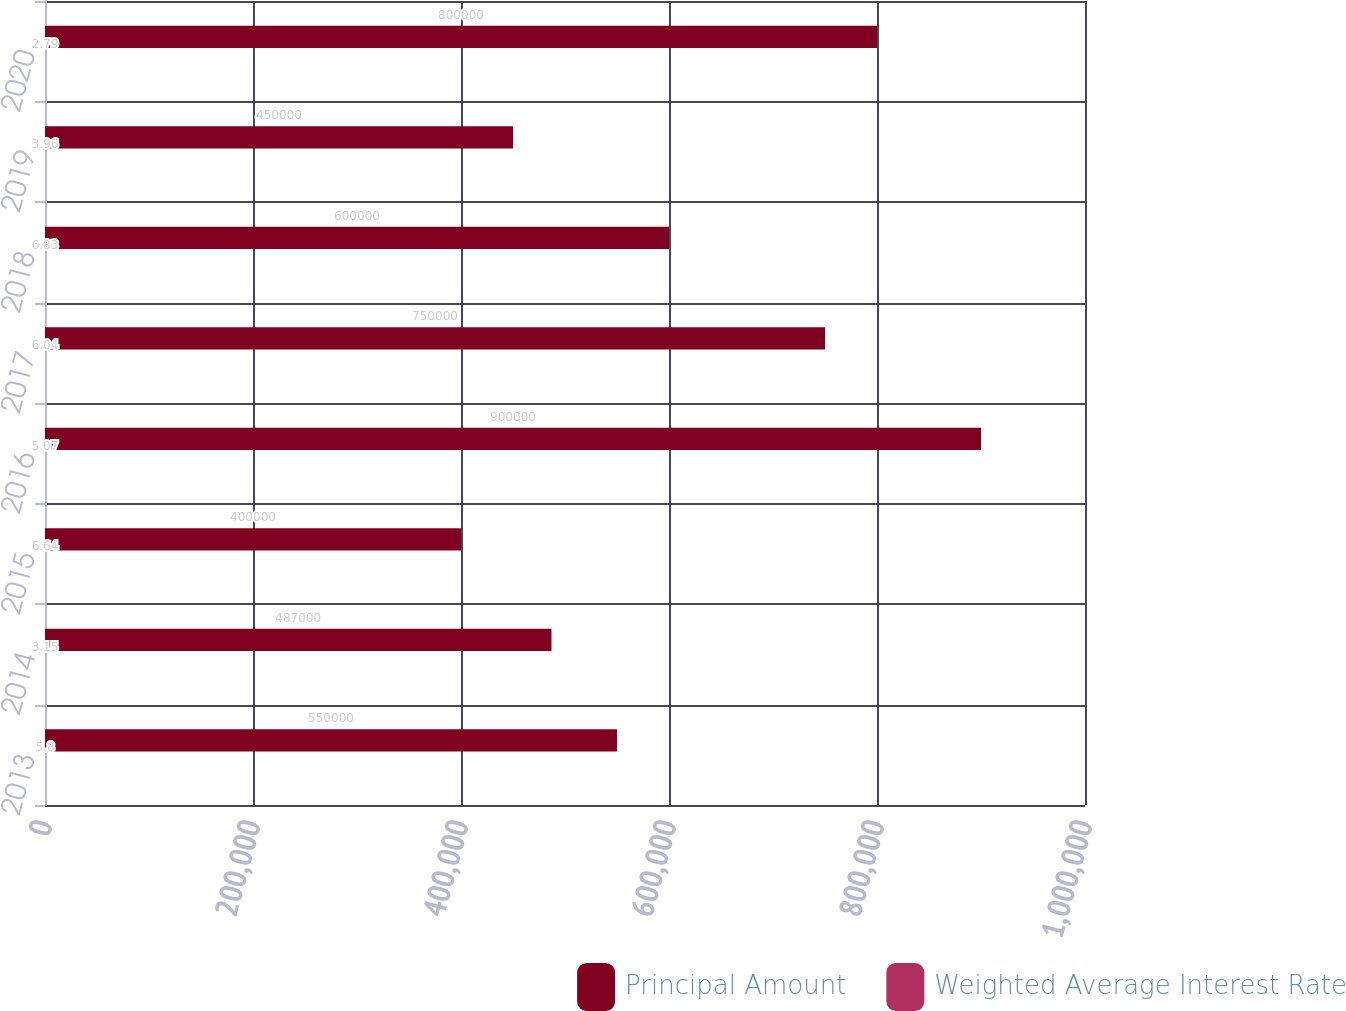Convert chart. <chart><loc_0><loc_0><loc_500><loc_500><stacked_bar_chart><ecel><fcel>2013<fcel>2014<fcel>2015<fcel>2016<fcel>2017<fcel>2018<fcel>2019<fcel>2020<nl><fcel>Principal Amount<fcel>550000<fcel>487000<fcel>400000<fcel>900000<fcel>750000<fcel>600000<fcel>450000<fcel>800000<nl><fcel>Weighted Average Interest Rate<fcel>5.8<fcel>3.15<fcel>6.64<fcel>5.07<fcel>6.04<fcel>6.83<fcel>3.96<fcel>2.79<nl></chart> 